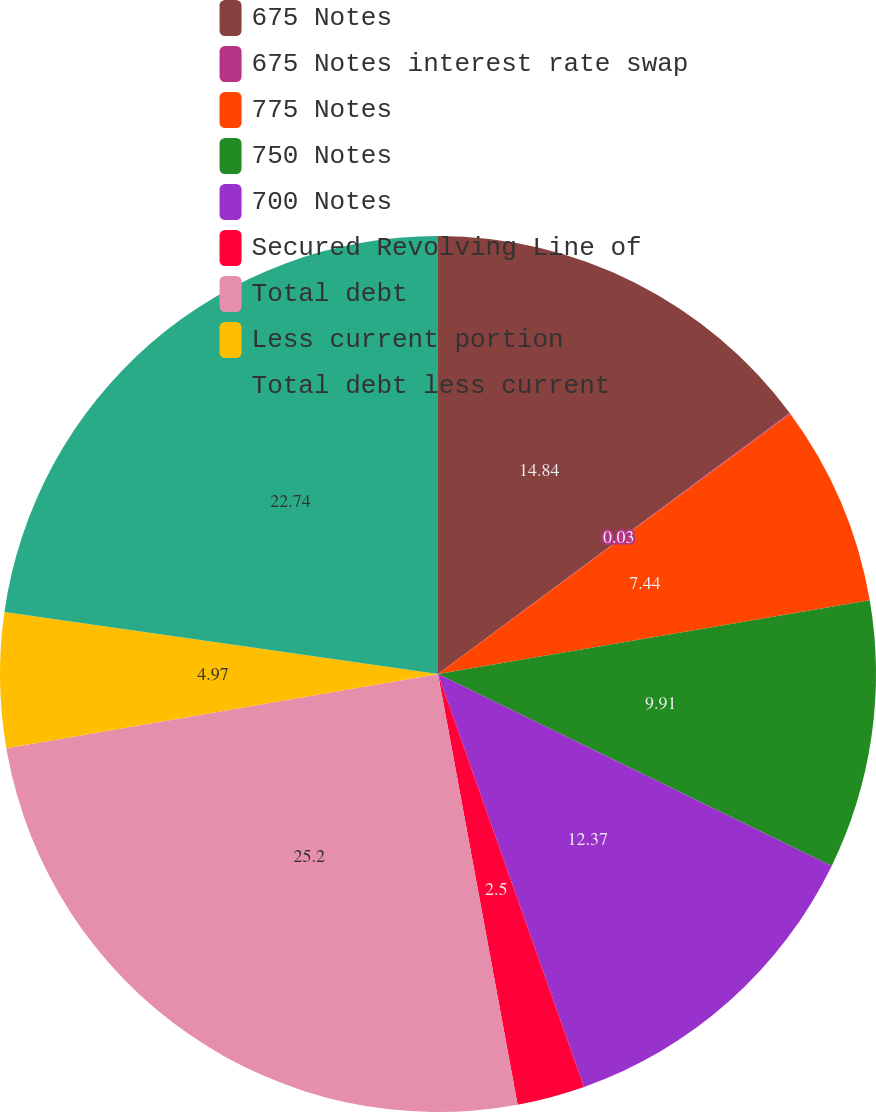Convert chart. <chart><loc_0><loc_0><loc_500><loc_500><pie_chart><fcel>675 Notes<fcel>675 Notes interest rate swap<fcel>775 Notes<fcel>750 Notes<fcel>700 Notes<fcel>Secured Revolving Line of<fcel>Total debt<fcel>Less current portion<fcel>Total debt less current<nl><fcel>14.84%<fcel>0.03%<fcel>7.44%<fcel>9.91%<fcel>12.37%<fcel>2.5%<fcel>25.2%<fcel>4.97%<fcel>22.74%<nl></chart> 